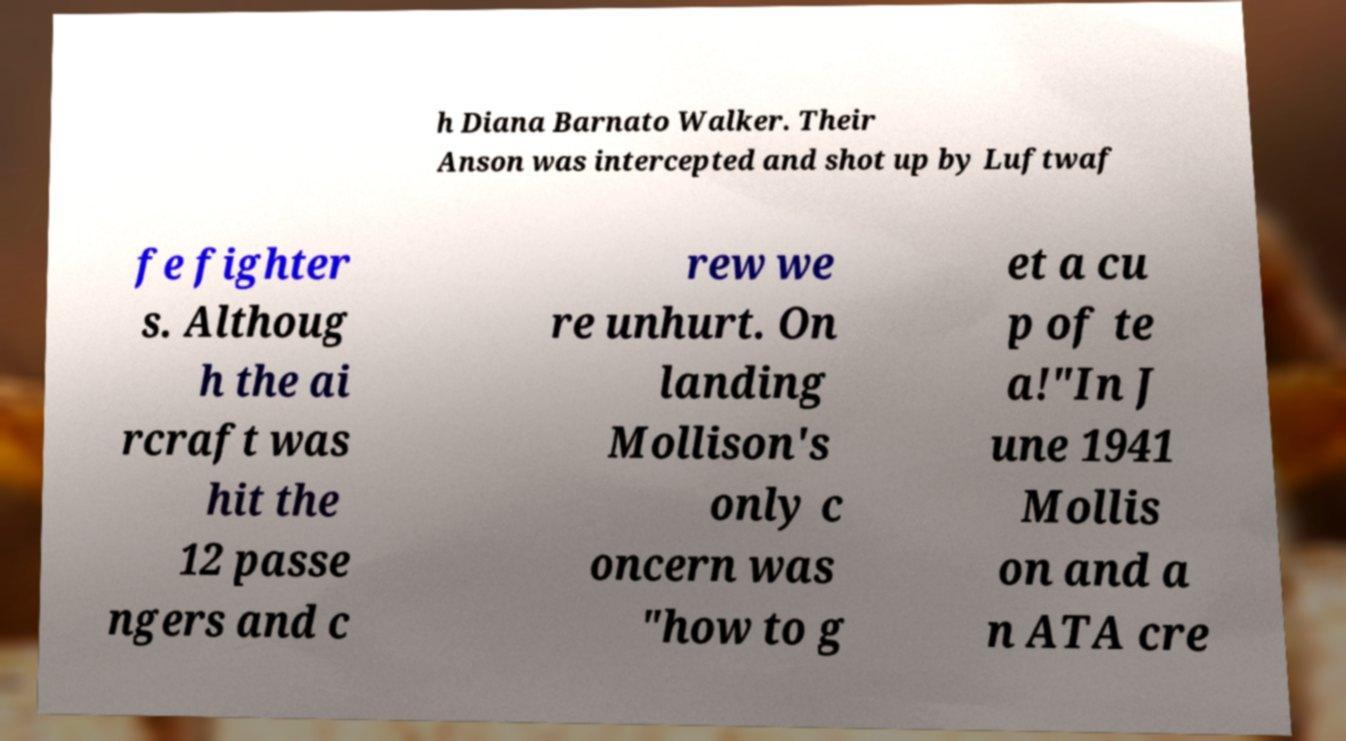Please identify and transcribe the text found in this image. h Diana Barnato Walker. Their Anson was intercepted and shot up by Luftwaf fe fighter s. Althoug h the ai rcraft was hit the 12 passe ngers and c rew we re unhurt. On landing Mollison's only c oncern was "how to g et a cu p of te a!"In J une 1941 Mollis on and a n ATA cre 